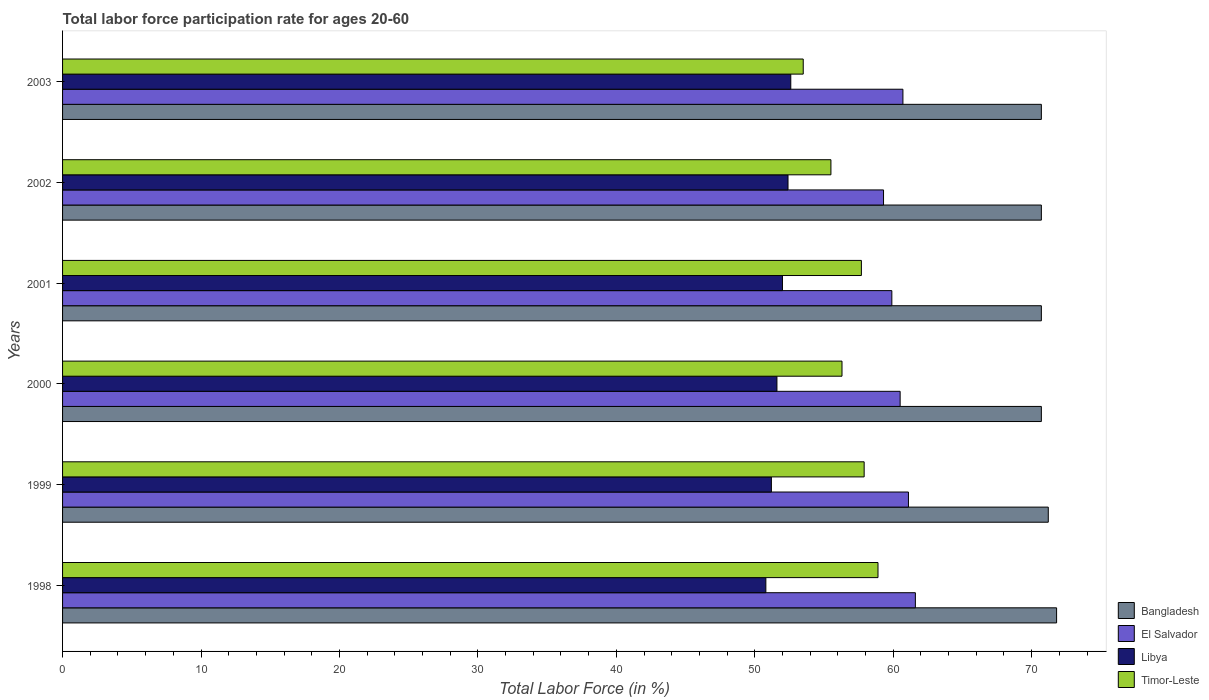How many different coloured bars are there?
Ensure brevity in your answer.  4. How many groups of bars are there?
Keep it short and to the point. 6. Are the number of bars on each tick of the Y-axis equal?
Provide a succinct answer. Yes. What is the labor force participation rate in El Salvador in 2000?
Keep it short and to the point. 60.5. Across all years, what is the maximum labor force participation rate in Timor-Leste?
Offer a very short reply. 58.9. Across all years, what is the minimum labor force participation rate in El Salvador?
Your answer should be compact. 59.3. What is the total labor force participation rate in El Salvador in the graph?
Keep it short and to the point. 363.1. What is the difference between the labor force participation rate in Bangladesh in 1999 and that in 2001?
Provide a short and direct response. 0.5. What is the difference between the labor force participation rate in El Salvador in 1998 and the labor force participation rate in Libya in 2002?
Provide a short and direct response. 9.2. What is the average labor force participation rate in Bangladesh per year?
Your answer should be compact. 70.97. In the year 1998, what is the difference between the labor force participation rate in El Salvador and labor force participation rate in Timor-Leste?
Make the answer very short. 2.7. In how many years, is the labor force participation rate in Timor-Leste greater than 14 %?
Keep it short and to the point. 6. What is the ratio of the labor force participation rate in Libya in 2000 to that in 2003?
Offer a terse response. 0.98. Is the labor force participation rate in Bangladesh in 2001 less than that in 2003?
Your answer should be very brief. No. What is the difference between the highest and the second highest labor force participation rate in Libya?
Offer a terse response. 0.2. What is the difference between the highest and the lowest labor force participation rate in Timor-Leste?
Provide a short and direct response. 5.4. In how many years, is the labor force participation rate in Timor-Leste greater than the average labor force participation rate in Timor-Leste taken over all years?
Your answer should be very brief. 3. Is it the case that in every year, the sum of the labor force participation rate in Bangladesh and labor force participation rate in Libya is greater than the sum of labor force participation rate in Timor-Leste and labor force participation rate in El Salvador?
Your answer should be compact. Yes. What does the 1st bar from the top in 1999 represents?
Your response must be concise. Timor-Leste. What does the 3rd bar from the bottom in 2001 represents?
Your answer should be compact. Libya. Is it the case that in every year, the sum of the labor force participation rate in Bangladesh and labor force participation rate in Timor-Leste is greater than the labor force participation rate in Libya?
Provide a succinct answer. Yes. How many years are there in the graph?
Keep it short and to the point. 6. Are the values on the major ticks of X-axis written in scientific E-notation?
Offer a terse response. No. Does the graph contain grids?
Your answer should be very brief. No. Where does the legend appear in the graph?
Make the answer very short. Bottom right. How are the legend labels stacked?
Provide a short and direct response. Vertical. What is the title of the graph?
Offer a very short reply. Total labor force participation rate for ages 20-60. Does "Lao PDR" appear as one of the legend labels in the graph?
Provide a short and direct response. No. What is the Total Labor Force (in %) of Bangladesh in 1998?
Keep it short and to the point. 71.8. What is the Total Labor Force (in %) of El Salvador in 1998?
Offer a terse response. 61.6. What is the Total Labor Force (in %) in Libya in 1998?
Provide a short and direct response. 50.8. What is the Total Labor Force (in %) in Timor-Leste in 1998?
Your answer should be very brief. 58.9. What is the Total Labor Force (in %) of Bangladesh in 1999?
Your answer should be very brief. 71.2. What is the Total Labor Force (in %) of El Salvador in 1999?
Make the answer very short. 61.1. What is the Total Labor Force (in %) of Libya in 1999?
Provide a short and direct response. 51.2. What is the Total Labor Force (in %) in Timor-Leste in 1999?
Give a very brief answer. 57.9. What is the Total Labor Force (in %) of Bangladesh in 2000?
Your answer should be compact. 70.7. What is the Total Labor Force (in %) of El Salvador in 2000?
Provide a succinct answer. 60.5. What is the Total Labor Force (in %) in Libya in 2000?
Give a very brief answer. 51.6. What is the Total Labor Force (in %) in Timor-Leste in 2000?
Your answer should be compact. 56.3. What is the Total Labor Force (in %) in Bangladesh in 2001?
Your response must be concise. 70.7. What is the Total Labor Force (in %) in El Salvador in 2001?
Keep it short and to the point. 59.9. What is the Total Labor Force (in %) of Libya in 2001?
Make the answer very short. 52. What is the Total Labor Force (in %) of Timor-Leste in 2001?
Your response must be concise. 57.7. What is the Total Labor Force (in %) of Bangladesh in 2002?
Keep it short and to the point. 70.7. What is the Total Labor Force (in %) in El Salvador in 2002?
Ensure brevity in your answer.  59.3. What is the Total Labor Force (in %) of Libya in 2002?
Offer a very short reply. 52.4. What is the Total Labor Force (in %) in Timor-Leste in 2002?
Make the answer very short. 55.5. What is the Total Labor Force (in %) of Bangladesh in 2003?
Provide a short and direct response. 70.7. What is the Total Labor Force (in %) in El Salvador in 2003?
Provide a succinct answer. 60.7. What is the Total Labor Force (in %) of Libya in 2003?
Keep it short and to the point. 52.6. What is the Total Labor Force (in %) of Timor-Leste in 2003?
Provide a short and direct response. 53.5. Across all years, what is the maximum Total Labor Force (in %) of Bangladesh?
Your response must be concise. 71.8. Across all years, what is the maximum Total Labor Force (in %) in El Salvador?
Your answer should be very brief. 61.6. Across all years, what is the maximum Total Labor Force (in %) of Libya?
Your answer should be very brief. 52.6. Across all years, what is the maximum Total Labor Force (in %) of Timor-Leste?
Your answer should be very brief. 58.9. Across all years, what is the minimum Total Labor Force (in %) in Bangladesh?
Make the answer very short. 70.7. Across all years, what is the minimum Total Labor Force (in %) in El Salvador?
Offer a very short reply. 59.3. Across all years, what is the minimum Total Labor Force (in %) of Libya?
Provide a succinct answer. 50.8. Across all years, what is the minimum Total Labor Force (in %) in Timor-Leste?
Provide a short and direct response. 53.5. What is the total Total Labor Force (in %) in Bangladesh in the graph?
Offer a very short reply. 425.8. What is the total Total Labor Force (in %) in El Salvador in the graph?
Provide a short and direct response. 363.1. What is the total Total Labor Force (in %) in Libya in the graph?
Give a very brief answer. 310.6. What is the total Total Labor Force (in %) of Timor-Leste in the graph?
Make the answer very short. 339.8. What is the difference between the Total Labor Force (in %) of Bangladesh in 1998 and that in 1999?
Keep it short and to the point. 0.6. What is the difference between the Total Labor Force (in %) of El Salvador in 1998 and that in 1999?
Your response must be concise. 0.5. What is the difference between the Total Labor Force (in %) of Timor-Leste in 1998 and that in 1999?
Provide a succinct answer. 1. What is the difference between the Total Labor Force (in %) of El Salvador in 1998 and that in 2000?
Offer a terse response. 1.1. What is the difference between the Total Labor Force (in %) in Libya in 1998 and that in 2000?
Keep it short and to the point. -0.8. What is the difference between the Total Labor Force (in %) in Timor-Leste in 1998 and that in 2000?
Your answer should be very brief. 2.6. What is the difference between the Total Labor Force (in %) of El Salvador in 1998 and that in 2001?
Your answer should be very brief. 1.7. What is the difference between the Total Labor Force (in %) in Timor-Leste in 1998 and that in 2001?
Your answer should be very brief. 1.2. What is the difference between the Total Labor Force (in %) in El Salvador in 1998 and that in 2002?
Offer a terse response. 2.3. What is the difference between the Total Labor Force (in %) in Libya in 1998 and that in 2002?
Provide a short and direct response. -1.6. What is the difference between the Total Labor Force (in %) of Timor-Leste in 1998 and that in 2002?
Offer a very short reply. 3.4. What is the difference between the Total Labor Force (in %) of El Salvador in 1998 and that in 2003?
Provide a short and direct response. 0.9. What is the difference between the Total Labor Force (in %) in Libya in 1998 and that in 2003?
Give a very brief answer. -1.8. What is the difference between the Total Labor Force (in %) in Timor-Leste in 1999 and that in 2000?
Provide a short and direct response. 1.6. What is the difference between the Total Labor Force (in %) in Bangladesh in 1999 and that in 2001?
Offer a terse response. 0.5. What is the difference between the Total Labor Force (in %) of Libya in 1999 and that in 2001?
Give a very brief answer. -0.8. What is the difference between the Total Labor Force (in %) of Timor-Leste in 1999 and that in 2001?
Keep it short and to the point. 0.2. What is the difference between the Total Labor Force (in %) in Bangladesh in 1999 and that in 2002?
Your answer should be very brief. 0.5. What is the difference between the Total Labor Force (in %) of Bangladesh in 1999 and that in 2003?
Provide a short and direct response. 0.5. What is the difference between the Total Labor Force (in %) in Libya in 1999 and that in 2003?
Provide a short and direct response. -1.4. What is the difference between the Total Labor Force (in %) in Timor-Leste in 2000 and that in 2001?
Keep it short and to the point. -1.4. What is the difference between the Total Labor Force (in %) of El Salvador in 2000 and that in 2002?
Offer a very short reply. 1.2. What is the difference between the Total Labor Force (in %) of Libya in 2000 and that in 2002?
Your answer should be very brief. -0.8. What is the difference between the Total Labor Force (in %) in Timor-Leste in 2000 and that in 2002?
Offer a terse response. 0.8. What is the difference between the Total Labor Force (in %) in Bangladesh in 2000 and that in 2003?
Your response must be concise. 0. What is the difference between the Total Labor Force (in %) in El Salvador in 2000 and that in 2003?
Your answer should be very brief. -0.2. What is the difference between the Total Labor Force (in %) in Libya in 2000 and that in 2003?
Your response must be concise. -1. What is the difference between the Total Labor Force (in %) of Timor-Leste in 2000 and that in 2003?
Your answer should be very brief. 2.8. What is the difference between the Total Labor Force (in %) of Bangladesh in 2001 and that in 2002?
Ensure brevity in your answer.  0. What is the difference between the Total Labor Force (in %) in El Salvador in 2001 and that in 2002?
Your answer should be compact. 0.6. What is the difference between the Total Labor Force (in %) of El Salvador in 2001 and that in 2003?
Make the answer very short. -0.8. What is the difference between the Total Labor Force (in %) in Timor-Leste in 2001 and that in 2003?
Keep it short and to the point. 4.2. What is the difference between the Total Labor Force (in %) of Bangladesh in 2002 and that in 2003?
Provide a short and direct response. 0. What is the difference between the Total Labor Force (in %) of El Salvador in 2002 and that in 2003?
Provide a short and direct response. -1.4. What is the difference between the Total Labor Force (in %) of Libya in 2002 and that in 2003?
Your answer should be very brief. -0.2. What is the difference between the Total Labor Force (in %) in Bangladesh in 1998 and the Total Labor Force (in %) in El Salvador in 1999?
Keep it short and to the point. 10.7. What is the difference between the Total Labor Force (in %) in Bangladesh in 1998 and the Total Labor Force (in %) in Libya in 1999?
Your response must be concise. 20.6. What is the difference between the Total Labor Force (in %) of El Salvador in 1998 and the Total Labor Force (in %) of Libya in 1999?
Provide a short and direct response. 10.4. What is the difference between the Total Labor Force (in %) in Bangladesh in 1998 and the Total Labor Force (in %) in Libya in 2000?
Make the answer very short. 20.2. What is the difference between the Total Labor Force (in %) in Libya in 1998 and the Total Labor Force (in %) in Timor-Leste in 2000?
Give a very brief answer. -5.5. What is the difference between the Total Labor Force (in %) of Bangladesh in 1998 and the Total Labor Force (in %) of Libya in 2001?
Your response must be concise. 19.8. What is the difference between the Total Labor Force (in %) of Bangladesh in 1998 and the Total Labor Force (in %) of Timor-Leste in 2001?
Make the answer very short. 14.1. What is the difference between the Total Labor Force (in %) of Libya in 1998 and the Total Labor Force (in %) of Timor-Leste in 2001?
Keep it short and to the point. -6.9. What is the difference between the Total Labor Force (in %) of Bangladesh in 1998 and the Total Labor Force (in %) of Timor-Leste in 2002?
Offer a terse response. 16.3. What is the difference between the Total Labor Force (in %) of Bangladesh in 1998 and the Total Labor Force (in %) of Libya in 2003?
Offer a very short reply. 19.2. What is the difference between the Total Labor Force (in %) in Bangladesh in 1998 and the Total Labor Force (in %) in Timor-Leste in 2003?
Give a very brief answer. 18.3. What is the difference between the Total Labor Force (in %) in El Salvador in 1998 and the Total Labor Force (in %) in Libya in 2003?
Your answer should be compact. 9. What is the difference between the Total Labor Force (in %) of El Salvador in 1998 and the Total Labor Force (in %) of Timor-Leste in 2003?
Make the answer very short. 8.1. What is the difference between the Total Labor Force (in %) in Libya in 1998 and the Total Labor Force (in %) in Timor-Leste in 2003?
Ensure brevity in your answer.  -2.7. What is the difference between the Total Labor Force (in %) of Bangladesh in 1999 and the Total Labor Force (in %) of El Salvador in 2000?
Ensure brevity in your answer.  10.7. What is the difference between the Total Labor Force (in %) of Bangladesh in 1999 and the Total Labor Force (in %) of Libya in 2000?
Offer a very short reply. 19.6. What is the difference between the Total Labor Force (in %) in El Salvador in 1999 and the Total Labor Force (in %) in Libya in 2000?
Your answer should be very brief. 9.5. What is the difference between the Total Labor Force (in %) of El Salvador in 1999 and the Total Labor Force (in %) of Timor-Leste in 2000?
Your answer should be very brief. 4.8. What is the difference between the Total Labor Force (in %) in Bangladesh in 1999 and the Total Labor Force (in %) in El Salvador in 2001?
Provide a succinct answer. 11.3. What is the difference between the Total Labor Force (in %) of Bangladesh in 1999 and the Total Labor Force (in %) of Timor-Leste in 2001?
Make the answer very short. 13.5. What is the difference between the Total Labor Force (in %) in El Salvador in 1999 and the Total Labor Force (in %) in Libya in 2001?
Your response must be concise. 9.1. What is the difference between the Total Labor Force (in %) in Bangladesh in 1999 and the Total Labor Force (in %) in El Salvador in 2003?
Your answer should be very brief. 10.5. What is the difference between the Total Labor Force (in %) in Bangladesh in 1999 and the Total Labor Force (in %) in Libya in 2003?
Provide a short and direct response. 18.6. What is the difference between the Total Labor Force (in %) of El Salvador in 1999 and the Total Labor Force (in %) of Libya in 2003?
Ensure brevity in your answer.  8.5. What is the difference between the Total Labor Force (in %) in Bangladesh in 2000 and the Total Labor Force (in %) in Libya in 2001?
Give a very brief answer. 18.7. What is the difference between the Total Labor Force (in %) of Bangladesh in 2000 and the Total Labor Force (in %) of Timor-Leste in 2001?
Provide a succinct answer. 13. What is the difference between the Total Labor Force (in %) in El Salvador in 2000 and the Total Labor Force (in %) in Libya in 2001?
Provide a succinct answer. 8.5. What is the difference between the Total Labor Force (in %) in Libya in 2000 and the Total Labor Force (in %) in Timor-Leste in 2001?
Provide a succinct answer. -6.1. What is the difference between the Total Labor Force (in %) of Bangladesh in 2000 and the Total Labor Force (in %) of El Salvador in 2002?
Provide a succinct answer. 11.4. What is the difference between the Total Labor Force (in %) of El Salvador in 2000 and the Total Labor Force (in %) of Timor-Leste in 2002?
Offer a terse response. 5. What is the difference between the Total Labor Force (in %) in Libya in 2000 and the Total Labor Force (in %) in Timor-Leste in 2002?
Provide a succinct answer. -3.9. What is the difference between the Total Labor Force (in %) of Bangladesh in 2000 and the Total Labor Force (in %) of El Salvador in 2003?
Keep it short and to the point. 10. What is the difference between the Total Labor Force (in %) in El Salvador in 2000 and the Total Labor Force (in %) in Libya in 2003?
Provide a short and direct response. 7.9. What is the difference between the Total Labor Force (in %) in El Salvador in 2000 and the Total Labor Force (in %) in Timor-Leste in 2003?
Make the answer very short. 7. What is the difference between the Total Labor Force (in %) of Libya in 2000 and the Total Labor Force (in %) of Timor-Leste in 2003?
Your answer should be compact. -1.9. What is the difference between the Total Labor Force (in %) of Bangladesh in 2001 and the Total Labor Force (in %) of Libya in 2002?
Your response must be concise. 18.3. What is the difference between the Total Labor Force (in %) in El Salvador in 2001 and the Total Labor Force (in %) in Timor-Leste in 2002?
Keep it short and to the point. 4.4. What is the difference between the Total Labor Force (in %) of Bangladesh in 2001 and the Total Labor Force (in %) of Libya in 2003?
Give a very brief answer. 18.1. What is the difference between the Total Labor Force (in %) of Bangladesh in 2001 and the Total Labor Force (in %) of Timor-Leste in 2003?
Provide a short and direct response. 17.2. What is the difference between the Total Labor Force (in %) of El Salvador in 2001 and the Total Labor Force (in %) of Libya in 2003?
Keep it short and to the point. 7.3. What is the difference between the Total Labor Force (in %) of Bangladesh in 2002 and the Total Labor Force (in %) of El Salvador in 2003?
Give a very brief answer. 10. What is the difference between the Total Labor Force (in %) of El Salvador in 2002 and the Total Labor Force (in %) of Libya in 2003?
Give a very brief answer. 6.7. What is the difference between the Total Labor Force (in %) in El Salvador in 2002 and the Total Labor Force (in %) in Timor-Leste in 2003?
Provide a succinct answer. 5.8. What is the average Total Labor Force (in %) in Bangladesh per year?
Provide a succinct answer. 70.97. What is the average Total Labor Force (in %) of El Salvador per year?
Offer a terse response. 60.52. What is the average Total Labor Force (in %) in Libya per year?
Ensure brevity in your answer.  51.77. What is the average Total Labor Force (in %) of Timor-Leste per year?
Provide a short and direct response. 56.63. In the year 1998, what is the difference between the Total Labor Force (in %) of El Salvador and Total Labor Force (in %) of Libya?
Your answer should be compact. 10.8. In the year 1998, what is the difference between the Total Labor Force (in %) in El Salvador and Total Labor Force (in %) in Timor-Leste?
Your answer should be compact. 2.7. In the year 1998, what is the difference between the Total Labor Force (in %) in Libya and Total Labor Force (in %) in Timor-Leste?
Provide a succinct answer. -8.1. In the year 1999, what is the difference between the Total Labor Force (in %) in Bangladesh and Total Labor Force (in %) in Libya?
Ensure brevity in your answer.  20. In the year 2000, what is the difference between the Total Labor Force (in %) of Bangladesh and Total Labor Force (in %) of El Salvador?
Offer a terse response. 10.2. In the year 2000, what is the difference between the Total Labor Force (in %) in El Salvador and Total Labor Force (in %) in Libya?
Your answer should be compact. 8.9. In the year 2000, what is the difference between the Total Labor Force (in %) in El Salvador and Total Labor Force (in %) in Timor-Leste?
Your answer should be compact. 4.2. In the year 2000, what is the difference between the Total Labor Force (in %) in Libya and Total Labor Force (in %) in Timor-Leste?
Provide a short and direct response. -4.7. In the year 2001, what is the difference between the Total Labor Force (in %) in El Salvador and Total Labor Force (in %) in Timor-Leste?
Give a very brief answer. 2.2. In the year 2001, what is the difference between the Total Labor Force (in %) in Libya and Total Labor Force (in %) in Timor-Leste?
Keep it short and to the point. -5.7. In the year 2002, what is the difference between the Total Labor Force (in %) of Bangladesh and Total Labor Force (in %) of El Salvador?
Keep it short and to the point. 11.4. In the year 2002, what is the difference between the Total Labor Force (in %) in Bangladesh and Total Labor Force (in %) in Libya?
Give a very brief answer. 18.3. In the year 2002, what is the difference between the Total Labor Force (in %) of Bangladesh and Total Labor Force (in %) of Timor-Leste?
Your answer should be compact. 15.2. In the year 2002, what is the difference between the Total Labor Force (in %) of El Salvador and Total Labor Force (in %) of Libya?
Your answer should be compact. 6.9. In the year 2003, what is the difference between the Total Labor Force (in %) in Bangladesh and Total Labor Force (in %) in Timor-Leste?
Make the answer very short. 17.2. In the year 2003, what is the difference between the Total Labor Force (in %) of El Salvador and Total Labor Force (in %) of Libya?
Provide a succinct answer. 8.1. In the year 2003, what is the difference between the Total Labor Force (in %) in Libya and Total Labor Force (in %) in Timor-Leste?
Your answer should be very brief. -0.9. What is the ratio of the Total Labor Force (in %) in Bangladesh in 1998 to that in 1999?
Offer a very short reply. 1.01. What is the ratio of the Total Labor Force (in %) in El Salvador in 1998 to that in 1999?
Offer a terse response. 1.01. What is the ratio of the Total Labor Force (in %) of Timor-Leste in 1998 to that in 1999?
Provide a succinct answer. 1.02. What is the ratio of the Total Labor Force (in %) in Bangladesh in 1998 to that in 2000?
Your answer should be very brief. 1.02. What is the ratio of the Total Labor Force (in %) of El Salvador in 1998 to that in 2000?
Provide a short and direct response. 1.02. What is the ratio of the Total Labor Force (in %) in Libya in 1998 to that in 2000?
Provide a short and direct response. 0.98. What is the ratio of the Total Labor Force (in %) of Timor-Leste in 1998 to that in 2000?
Provide a short and direct response. 1.05. What is the ratio of the Total Labor Force (in %) of Bangladesh in 1998 to that in 2001?
Ensure brevity in your answer.  1.02. What is the ratio of the Total Labor Force (in %) in El Salvador in 1998 to that in 2001?
Make the answer very short. 1.03. What is the ratio of the Total Labor Force (in %) in Libya in 1998 to that in 2001?
Offer a very short reply. 0.98. What is the ratio of the Total Labor Force (in %) of Timor-Leste in 1998 to that in 2001?
Your answer should be very brief. 1.02. What is the ratio of the Total Labor Force (in %) of Bangladesh in 1998 to that in 2002?
Give a very brief answer. 1.02. What is the ratio of the Total Labor Force (in %) in El Salvador in 1998 to that in 2002?
Provide a succinct answer. 1.04. What is the ratio of the Total Labor Force (in %) in Libya in 1998 to that in 2002?
Keep it short and to the point. 0.97. What is the ratio of the Total Labor Force (in %) of Timor-Leste in 1998 to that in 2002?
Your response must be concise. 1.06. What is the ratio of the Total Labor Force (in %) of Bangladesh in 1998 to that in 2003?
Provide a short and direct response. 1.02. What is the ratio of the Total Labor Force (in %) in El Salvador in 1998 to that in 2003?
Provide a short and direct response. 1.01. What is the ratio of the Total Labor Force (in %) in Libya in 1998 to that in 2003?
Offer a very short reply. 0.97. What is the ratio of the Total Labor Force (in %) in Timor-Leste in 1998 to that in 2003?
Your answer should be very brief. 1.1. What is the ratio of the Total Labor Force (in %) in Bangladesh in 1999 to that in 2000?
Offer a very short reply. 1.01. What is the ratio of the Total Labor Force (in %) of El Salvador in 1999 to that in 2000?
Offer a terse response. 1.01. What is the ratio of the Total Labor Force (in %) in Timor-Leste in 1999 to that in 2000?
Provide a short and direct response. 1.03. What is the ratio of the Total Labor Force (in %) of Bangladesh in 1999 to that in 2001?
Make the answer very short. 1.01. What is the ratio of the Total Labor Force (in %) in Libya in 1999 to that in 2001?
Your response must be concise. 0.98. What is the ratio of the Total Labor Force (in %) of Timor-Leste in 1999 to that in 2001?
Your answer should be very brief. 1. What is the ratio of the Total Labor Force (in %) of Bangladesh in 1999 to that in 2002?
Make the answer very short. 1.01. What is the ratio of the Total Labor Force (in %) of El Salvador in 1999 to that in 2002?
Make the answer very short. 1.03. What is the ratio of the Total Labor Force (in %) of Libya in 1999 to that in 2002?
Provide a succinct answer. 0.98. What is the ratio of the Total Labor Force (in %) of Timor-Leste in 1999 to that in 2002?
Your response must be concise. 1.04. What is the ratio of the Total Labor Force (in %) of Bangladesh in 1999 to that in 2003?
Offer a terse response. 1.01. What is the ratio of the Total Labor Force (in %) in El Salvador in 1999 to that in 2003?
Offer a terse response. 1.01. What is the ratio of the Total Labor Force (in %) in Libya in 1999 to that in 2003?
Make the answer very short. 0.97. What is the ratio of the Total Labor Force (in %) in Timor-Leste in 1999 to that in 2003?
Your answer should be very brief. 1.08. What is the ratio of the Total Labor Force (in %) of El Salvador in 2000 to that in 2001?
Your answer should be compact. 1.01. What is the ratio of the Total Labor Force (in %) in Timor-Leste in 2000 to that in 2001?
Offer a terse response. 0.98. What is the ratio of the Total Labor Force (in %) of El Salvador in 2000 to that in 2002?
Provide a short and direct response. 1.02. What is the ratio of the Total Labor Force (in %) of Libya in 2000 to that in 2002?
Offer a very short reply. 0.98. What is the ratio of the Total Labor Force (in %) in Timor-Leste in 2000 to that in 2002?
Your answer should be very brief. 1.01. What is the ratio of the Total Labor Force (in %) of Timor-Leste in 2000 to that in 2003?
Keep it short and to the point. 1.05. What is the ratio of the Total Labor Force (in %) in Bangladesh in 2001 to that in 2002?
Give a very brief answer. 1. What is the ratio of the Total Labor Force (in %) in Timor-Leste in 2001 to that in 2002?
Your response must be concise. 1.04. What is the ratio of the Total Labor Force (in %) in Bangladesh in 2001 to that in 2003?
Your answer should be compact. 1. What is the ratio of the Total Labor Force (in %) in Timor-Leste in 2001 to that in 2003?
Give a very brief answer. 1.08. What is the ratio of the Total Labor Force (in %) of El Salvador in 2002 to that in 2003?
Give a very brief answer. 0.98. What is the ratio of the Total Labor Force (in %) in Libya in 2002 to that in 2003?
Give a very brief answer. 1. What is the ratio of the Total Labor Force (in %) of Timor-Leste in 2002 to that in 2003?
Provide a short and direct response. 1.04. What is the difference between the highest and the second highest Total Labor Force (in %) in Timor-Leste?
Make the answer very short. 1. What is the difference between the highest and the lowest Total Labor Force (in %) in Bangladesh?
Provide a short and direct response. 1.1. What is the difference between the highest and the lowest Total Labor Force (in %) in El Salvador?
Your answer should be very brief. 2.3. 